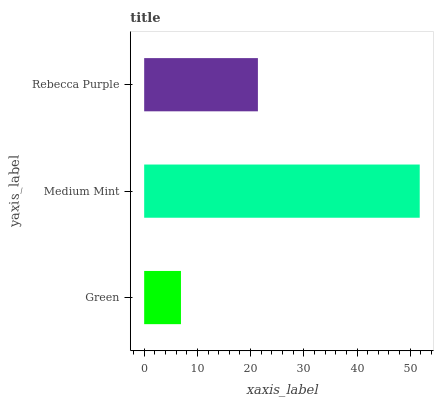Is Green the minimum?
Answer yes or no. Yes. Is Medium Mint the maximum?
Answer yes or no. Yes. Is Rebecca Purple the minimum?
Answer yes or no. No. Is Rebecca Purple the maximum?
Answer yes or no. No. Is Medium Mint greater than Rebecca Purple?
Answer yes or no. Yes. Is Rebecca Purple less than Medium Mint?
Answer yes or no. Yes. Is Rebecca Purple greater than Medium Mint?
Answer yes or no. No. Is Medium Mint less than Rebecca Purple?
Answer yes or no. No. Is Rebecca Purple the high median?
Answer yes or no. Yes. Is Rebecca Purple the low median?
Answer yes or no. Yes. Is Medium Mint the high median?
Answer yes or no. No. Is Green the low median?
Answer yes or no. No. 